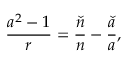<formula> <loc_0><loc_0><loc_500><loc_500>\frac { a ^ { 2 } - 1 } { r } = \frac { \check { n } } { n } - \frac { \check { a } } { a } ,</formula> 